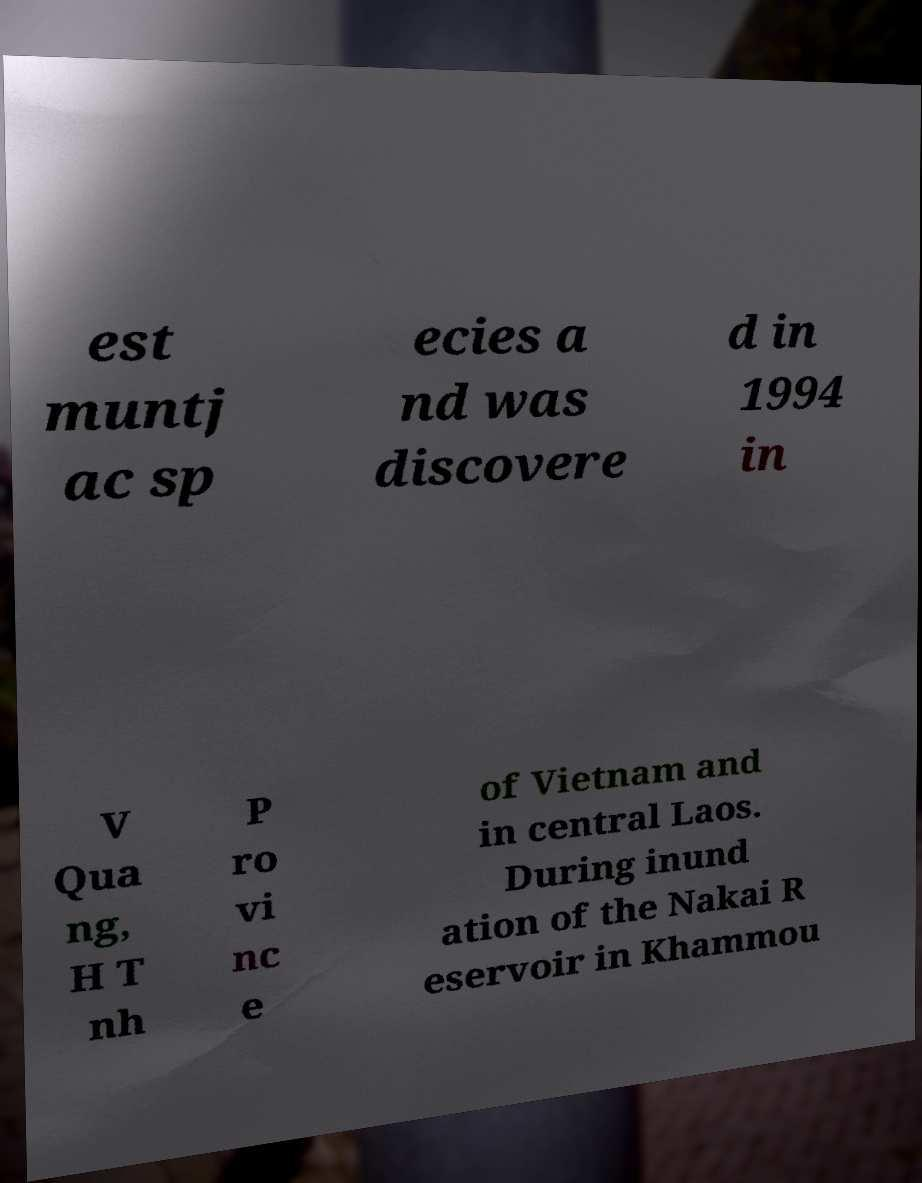Can you accurately transcribe the text from the provided image for me? est muntj ac sp ecies a nd was discovere d in 1994 in V Qua ng, H T nh P ro vi nc e of Vietnam and in central Laos. During inund ation of the Nakai R eservoir in Khammou 